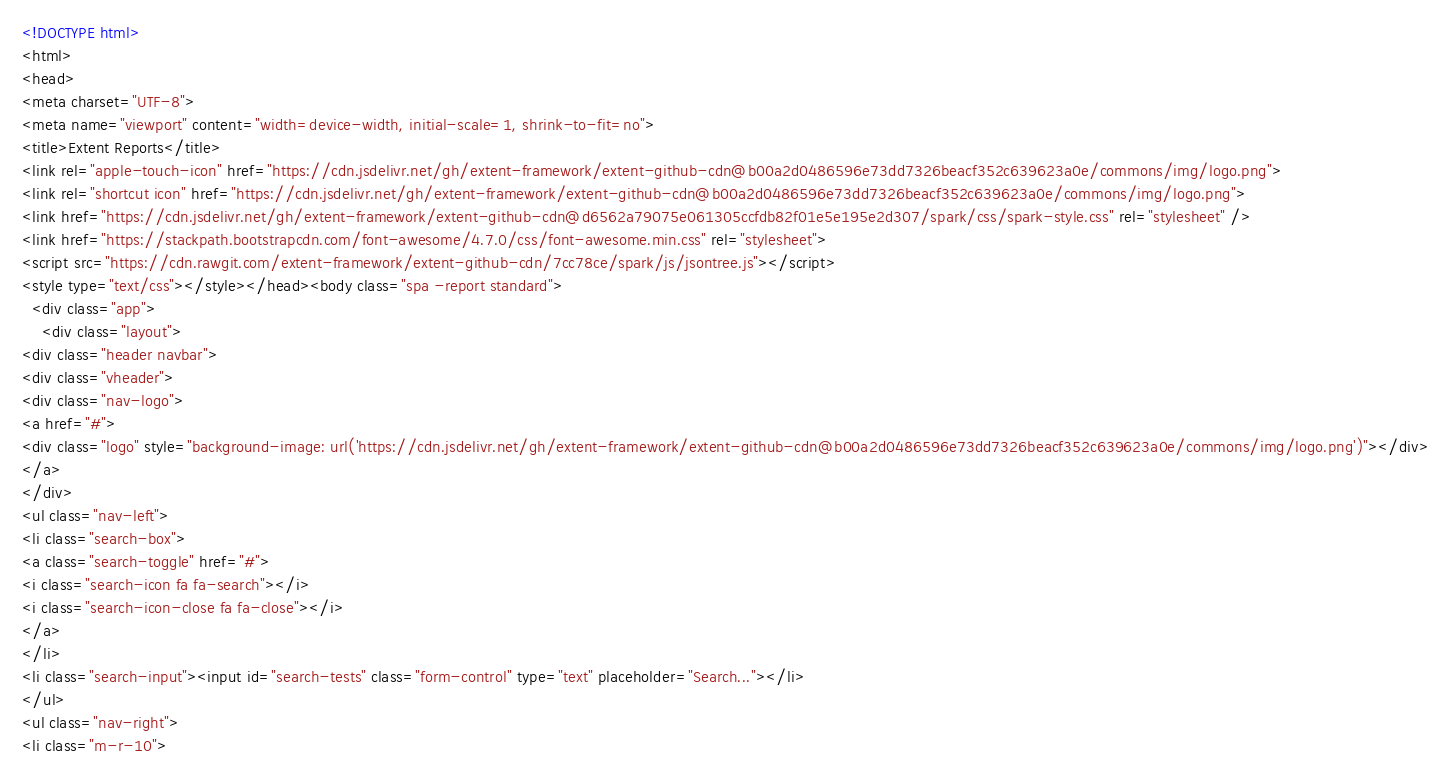<code> <loc_0><loc_0><loc_500><loc_500><_HTML_>

<!DOCTYPE html>
<html>
<head>
<meta charset="UTF-8">
<meta name="viewport" content="width=device-width, initial-scale=1, shrink-to-fit=no">
<title>Extent Reports</title>
<link rel="apple-touch-icon" href="https://cdn.jsdelivr.net/gh/extent-framework/extent-github-cdn@b00a2d0486596e73dd7326beacf352c639623a0e/commons/img/logo.png">
<link rel="shortcut icon" href="https://cdn.jsdelivr.net/gh/extent-framework/extent-github-cdn@b00a2d0486596e73dd7326beacf352c639623a0e/commons/img/logo.png">
<link href="https://cdn.jsdelivr.net/gh/extent-framework/extent-github-cdn@d6562a79075e061305ccfdb82f01e5e195e2d307/spark/css/spark-style.css" rel="stylesheet" />
<link href="https://stackpath.bootstrapcdn.com/font-awesome/4.7.0/css/font-awesome.min.css" rel="stylesheet">
<script src="https://cdn.rawgit.com/extent-framework/extent-github-cdn/7cc78ce/spark/js/jsontree.js"></script>
<style type="text/css"></style></head><body class="spa -report standard">
  <div class="app">
    <div class="layout">
<div class="header navbar">
<div class="vheader">
<div class="nav-logo">
<a href="#">
<div class="logo" style="background-image: url('https://cdn.jsdelivr.net/gh/extent-framework/extent-github-cdn@b00a2d0486596e73dd7326beacf352c639623a0e/commons/img/logo.png')"></div>
</a>
</div>
<ul class="nav-left">
<li class="search-box">
<a class="search-toggle" href="#">
<i class="search-icon fa fa-search"></i>
<i class="search-icon-close fa fa-close"></i>
</a>
</li>
<li class="search-input"><input id="search-tests" class="form-control" type="text" placeholder="Search..."></li>
</ul>
<ul class="nav-right">
<li class="m-r-10"></code> 